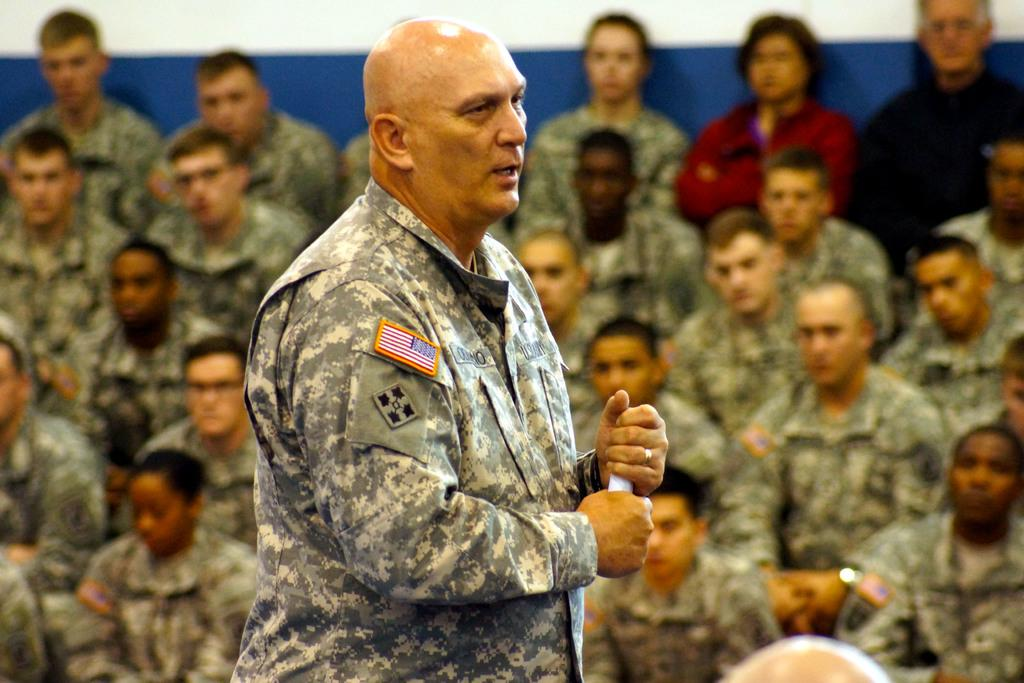What is the man in the middle of the image doing? The man is standing in the middle of the image. What is the man holding in the image? The man is holding a paper. Are there any other people in the image? Yes, there are people sitting beside the man. What can be seen at the top of the image? There is a wall at the top of the image. How many fish can be seen swimming near the man in the image? There are no fish visible in the image; it features a man standing and holding a paper, with people sitting beside him and a wall at the top. 